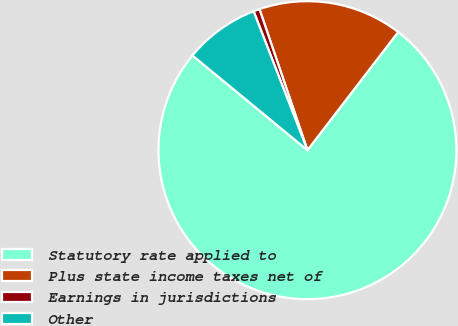<chart> <loc_0><loc_0><loc_500><loc_500><pie_chart><fcel>Statutory rate applied to<fcel>Plus state income taxes net of<fcel>Earnings in jurisdictions<fcel>Other<nl><fcel>75.54%<fcel>15.64%<fcel>0.67%<fcel>8.15%<nl></chart> 